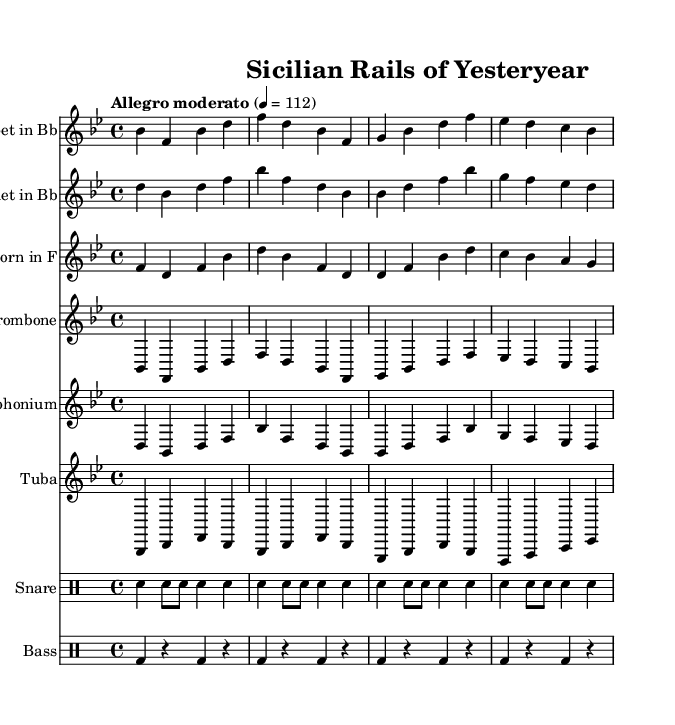What is the key signature of this music? The key signature of the music is indicated at the beginning of the score. It has two flat notes, which identifies it as B flat major.
Answer: B flat major What is the time signature of the music? The time signature is displayed in the beginning section of the score. It shows that there are four beats per measure, indicated by the "4/4."
Answer: 4/4 What is the tempo marking of this piece? The tempo marking is located above the staff, stating "Allegro moderato" and a metronome marking of 112 beats per minute.
Answer: Allegro moderato How many instruments are featured in this score? The score features a total of six instruments, indicated by the different staffs present for each instrument type.
Answer: Six What is the name of the piece as indicated in the header? The title of the piece is prominently displayed at the top of the score, named "Sicilian Rails of Yesteryear."
Answer: Sicilian Rails of Yesteryear Which family of instruments does the euphonium belong to? The euphonium is noted in the score among brass instruments, as indicated by its staff position and common usage.
Answer: Brass What kind of ensemble does this music likely represent based on its instrumentation? The blend of brass instruments along with drums suggests it is a brass band, which traditionally performs marches like this one.
Answer: Brass band 